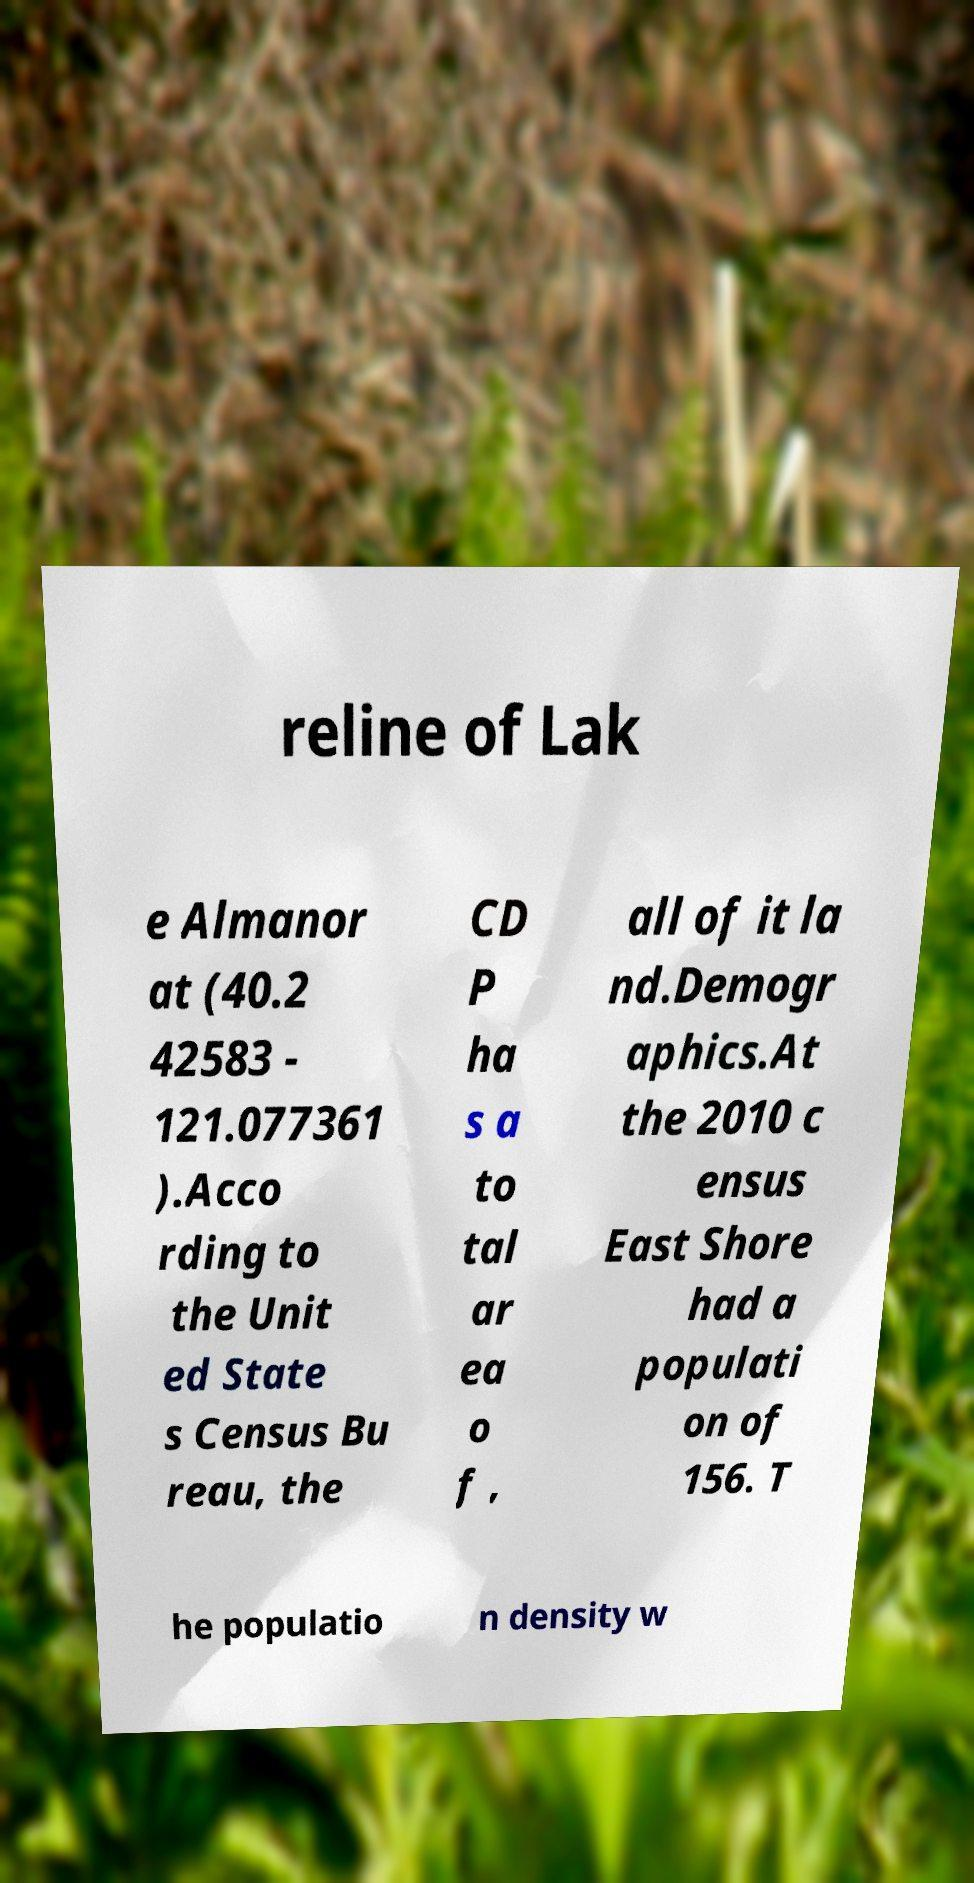Please identify and transcribe the text found in this image. reline of Lak e Almanor at (40.2 42583 - 121.077361 ).Acco rding to the Unit ed State s Census Bu reau, the CD P ha s a to tal ar ea o f , all of it la nd.Demogr aphics.At the 2010 c ensus East Shore had a populati on of 156. T he populatio n density w 